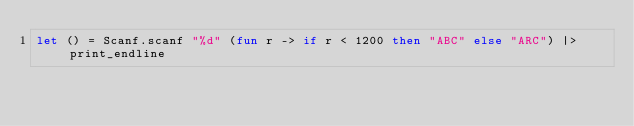<code> <loc_0><loc_0><loc_500><loc_500><_OCaml_>let () = Scanf.scanf "%d" (fun r -> if r < 1200 then "ABC" else "ARC") |> print_endline
</code> 